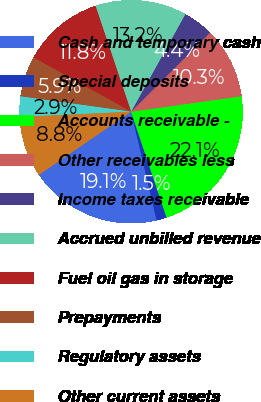Convert chart. <chart><loc_0><loc_0><loc_500><loc_500><pie_chart><fcel>Cash and temporary cash<fcel>Special deposits<fcel>Accounts receivable -<fcel>Other receivables less<fcel>Income taxes receivable<fcel>Accrued unbilled revenue<fcel>Fuel oil gas in storage<fcel>Prepayments<fcel>Regulatory assets<fcel>Other current assets<nl><fcel>19.12%<fcel>1.47%<fcel>22.06%<fcel>10.29%<fcel>4.41%<fcel>13.24%<fcel>11.76%<fcel>5.88%<fcel>2.94%<fcel>8.82%<nl></chart> 